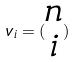<formula> <loc_0><loc_0><loc_500><loc_500>v _ { i } = ( \begin{matrix} n \\ i \end{matrix} )</formula> 